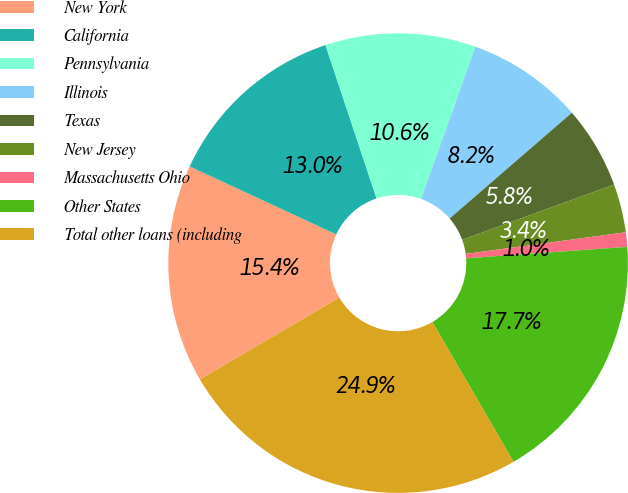Convert chart. <chart><loc_0><loc_0><loc_500><loc_500><pie_chart><fcel>New York<fcel>California<fcel>Pennsylvania<fcel>Illinois<fcel>Texas<fcel>New Jersey<fcel>Massachusetts Ohio<fcel>Other States<fcel>Total other loans (including<nl><fcel>15.36%<fcel>12.97%<fcel>10.58%<fcel>8.19%<fcel>5.8%<fcel>3.41%<fcel>1.02%<fcel>17.75%<fcel>24.93%<nl></chart> 